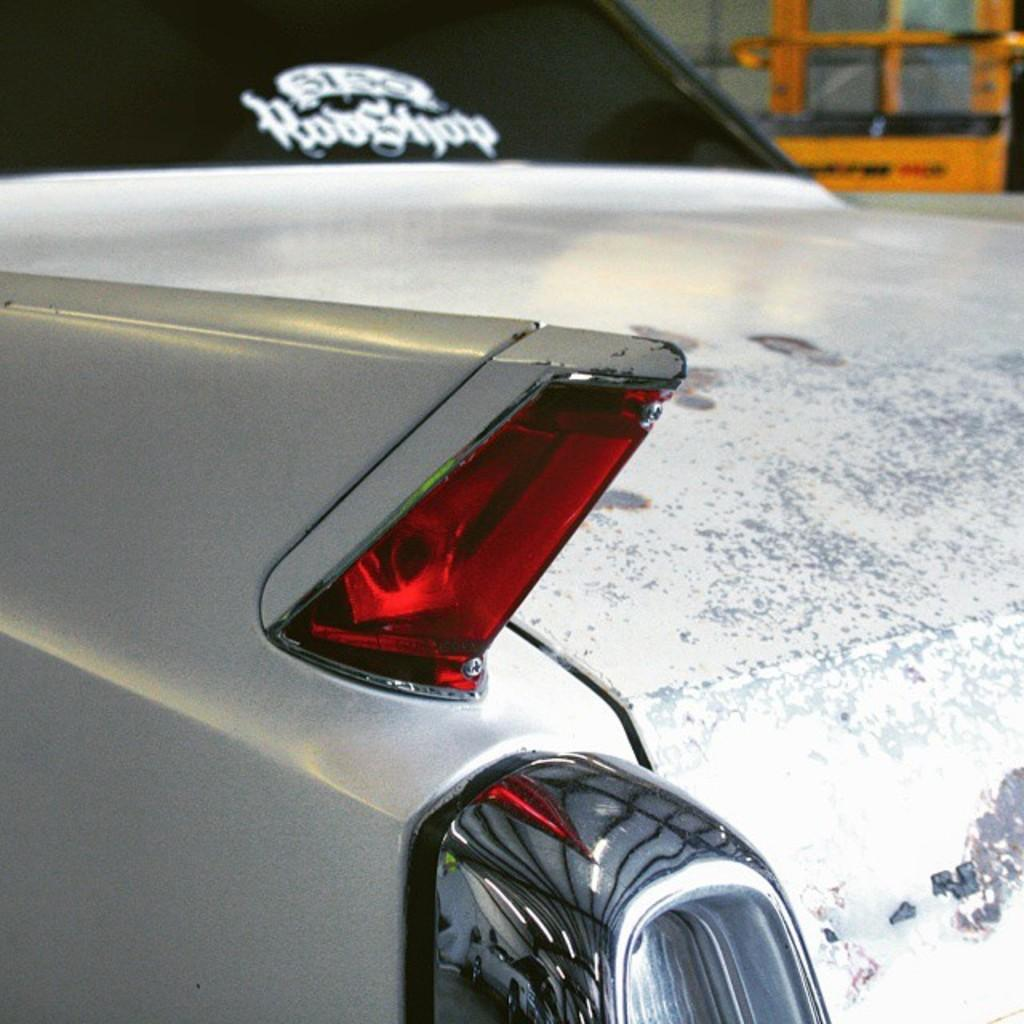What is the main subject of the image? The main subject of the image is a car. Can you describe the unspecified object behind the car? Unfortunately, the facts provided do not give any details about the object behind the car. How many shoes are visible in the image? There are no shoes present in the image. What type of potato is being used as a parent in the image? There is no potato or parent depicted in the image. 